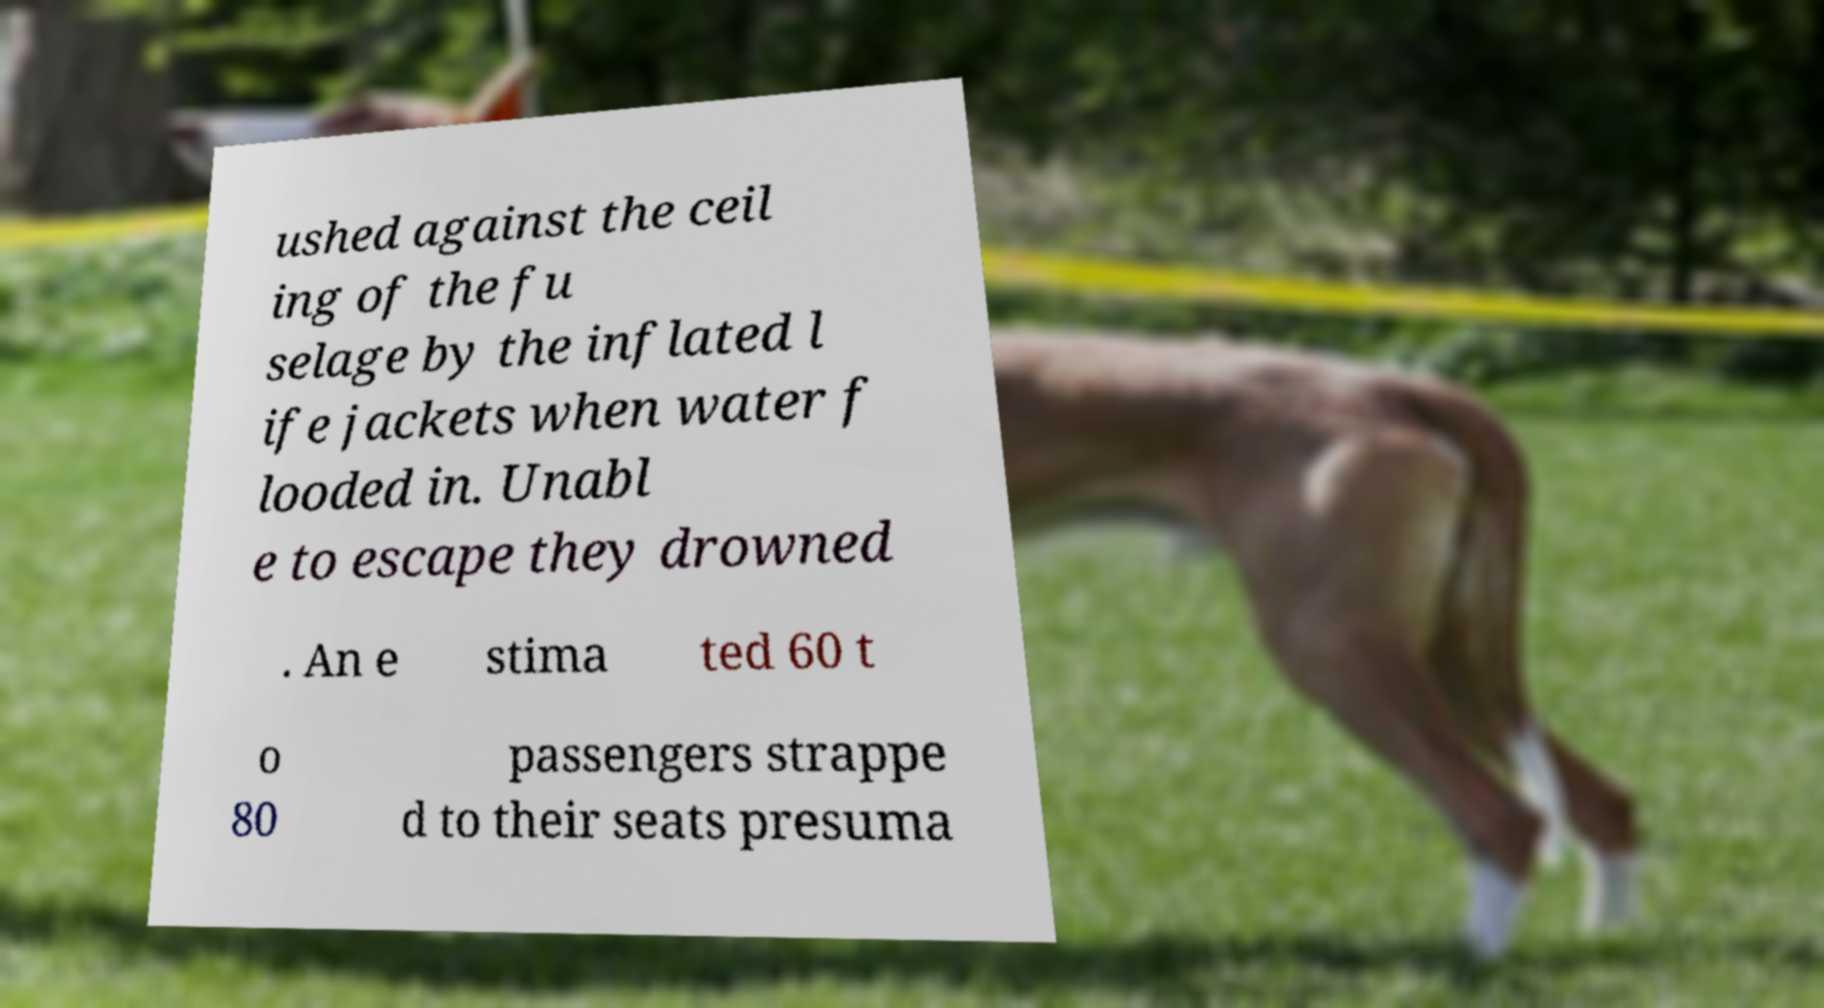Can you accurately transcribe the text from the provided image for me? ushed against the ceil ing of the fu selage by the inflated l ife jackets when water f looded in. Unabl e to escape they drowned . An e stima ted 60 t o 80 passengers strappe d to their seats presuma 